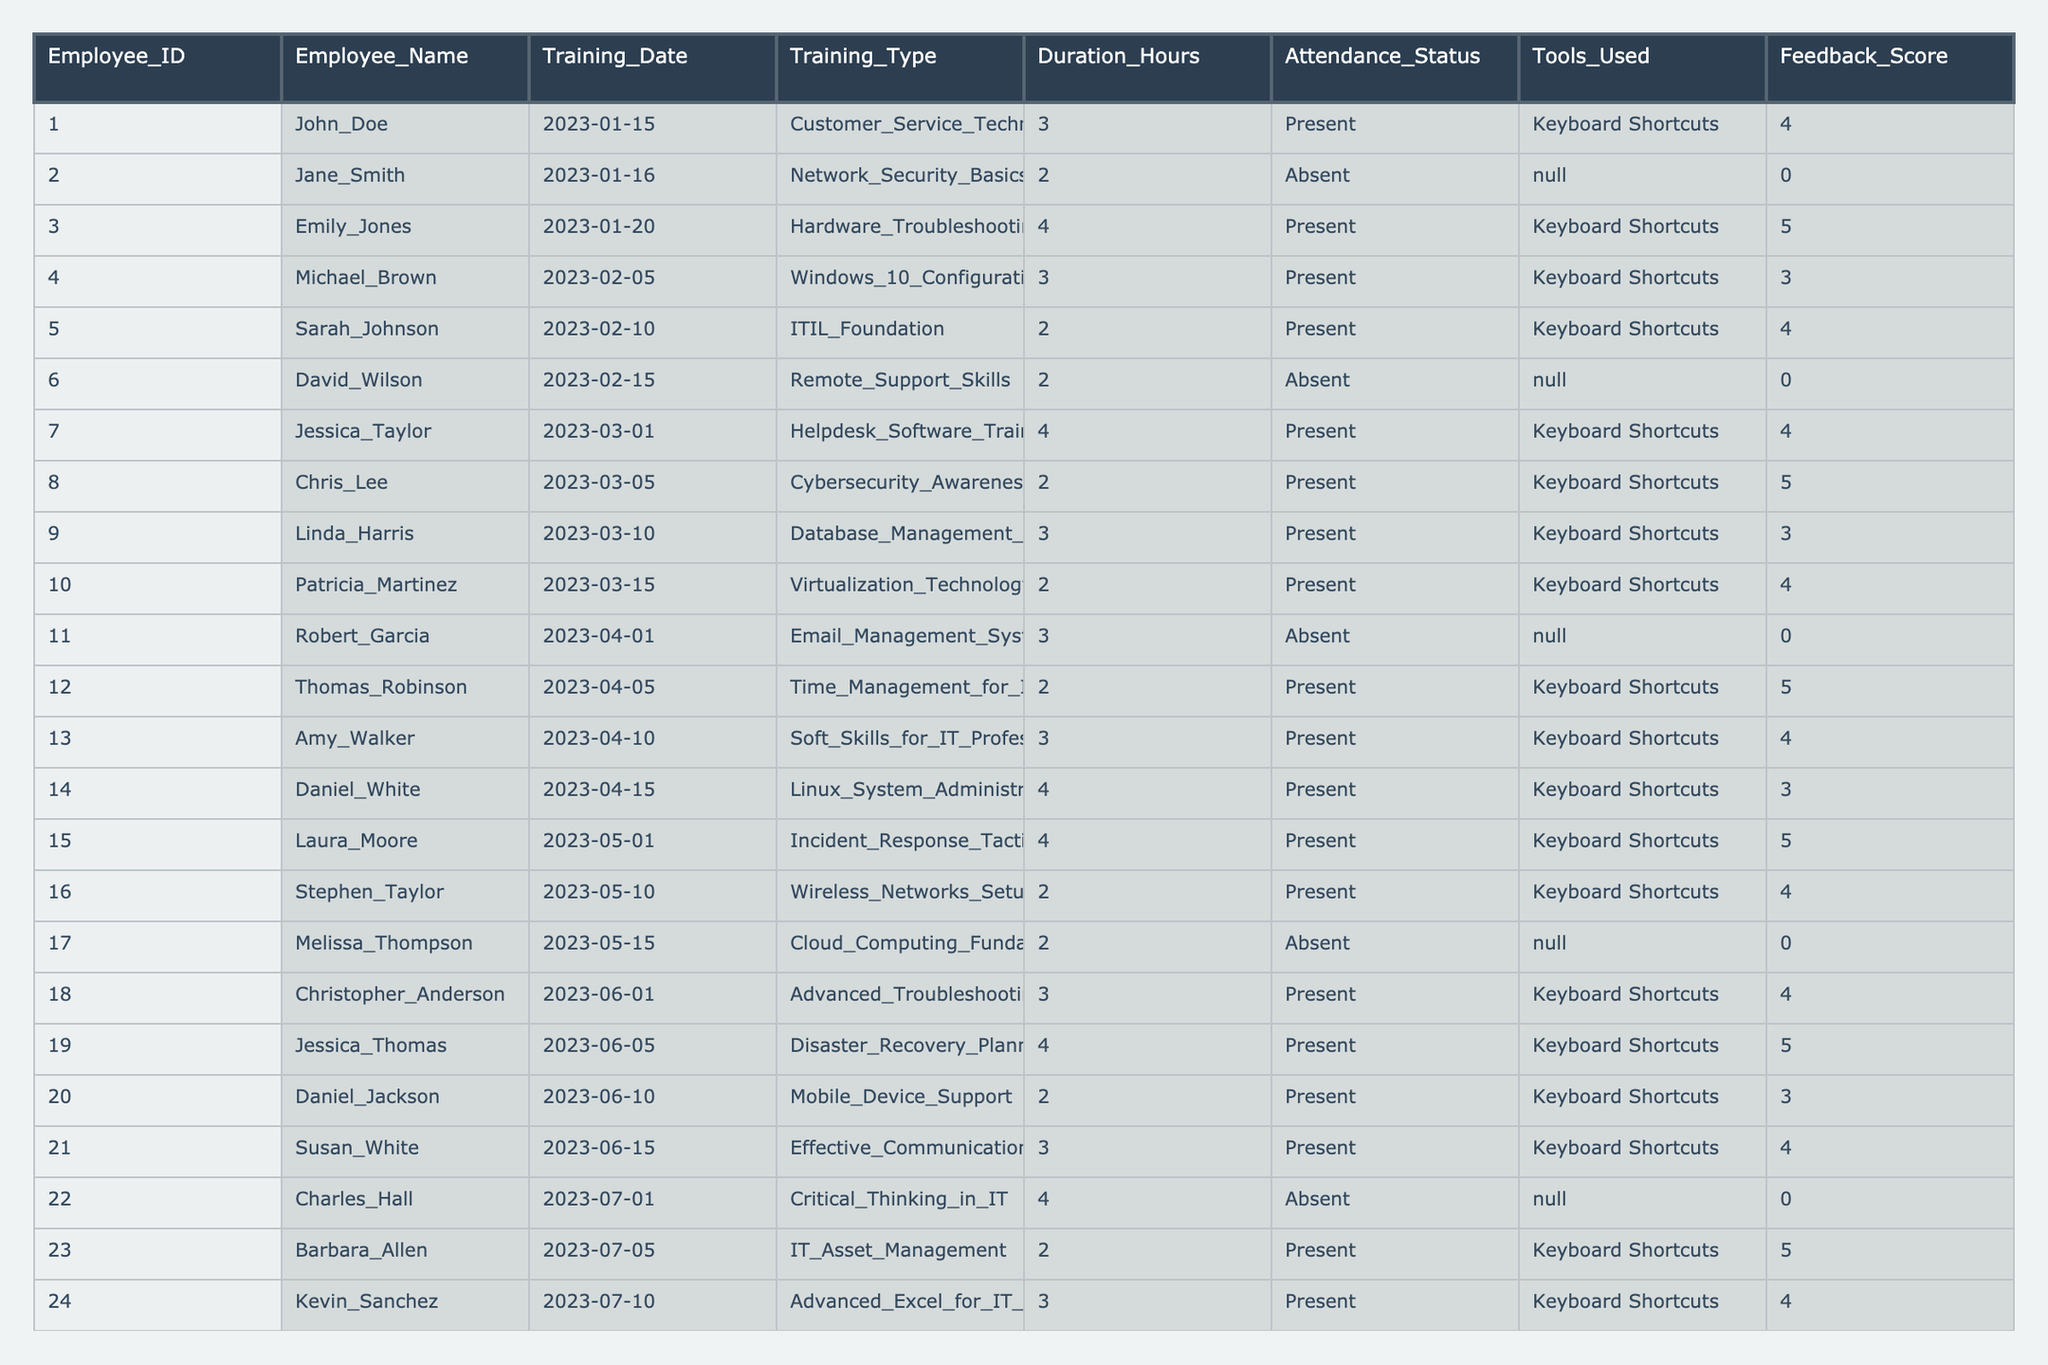What is the total number of training sessions attended by the IT support staff? By counting the number of rows in the Attendance_Status column where the status is 'Present', we find there are 19 sessions attended.
Answer: 19 How many training sessions had an attendance status of 'Absent'? By counting the occurrences of 'Absent' in the Attendance_Status column, we find there are 6 instances.
Answer: 6 Which employee received the highest feedback score and what was that score? Looking through the Feedback_Score column, the maximum score is 5, which was achieved by employees Emily_Jones, Chris_Lee, Thomas_Robinson, Jessica_Thomas, and Laura_Moore.
Answer: 5 What training session had the longest duration and what was the duration? Scanning the Duration_Hours column, the longest session is Hardware_Troubleshooting with a duration of 4 hours.
Answer: 4 How many training sessions were conducted in the month of June? By checking the Training_Date column for the month of June, there are 4 training sessions listed.
Answer: 4 What is the average feedback score for sessions where employees used keyboard shortcuts? Summing the Feedback_Scores for all 'Present' status sessions (scores are 4, 5, 3, 4, 4, 5, 4, 3, 4, 5) gives a total of 42 over 10 sessions. The average is 42/10 = 4.2.
Answer: 4.2 Did any employee attend multiple training sessions related to Network Security? Only Jane_Smith attended Network_Security_Basics training, hence, no other employee attended that training.
Answer: No Which employees attended the training session on Cloud Computing Fundamentals? The session on Cloud Computing Fundamentals was attended by Melissa_Thompson, as she is the only one with a 'Present' status on that date.
Answer: Melissa_Thompson How many employees used tools other than keyboard shortcuts? By checking the Tools_Used column, David_Wilson and Stephen_Taylor used 'N/A' for their training, which means they did not use any tools, resulting in 2 employees.
Answer: 2 What percentage of the training sessions had an attendance status of 'Present'? There are 25 training sessions total, and 19 had 'Present' status. The percentage is (19/25) * 100 = 76%.
Answer: 76% 